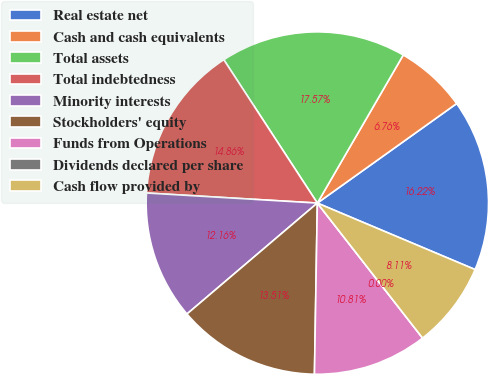Convert chart. <chart><loc_0><loc_0><loc_500><loc_500><pie_chart><fcel>Real estate net<fcel>Cash and cash equivalents<fcel>Total assets<fcel>Total indebtedness<fcel>Minority interests<fcel>Stockholders' equity<fcel>Funds from Operations<fcel>Dividends declared per share<fcel>Cash flow provided by<nl><fcel>16.22%<fcel>6.76%<fcel>17.57%<fcel>14.86%<fcel>12.16%<fcel>13.51%<fcel>10.81%<fcel>0.0%<fcel>8.11%<nl></chart> 